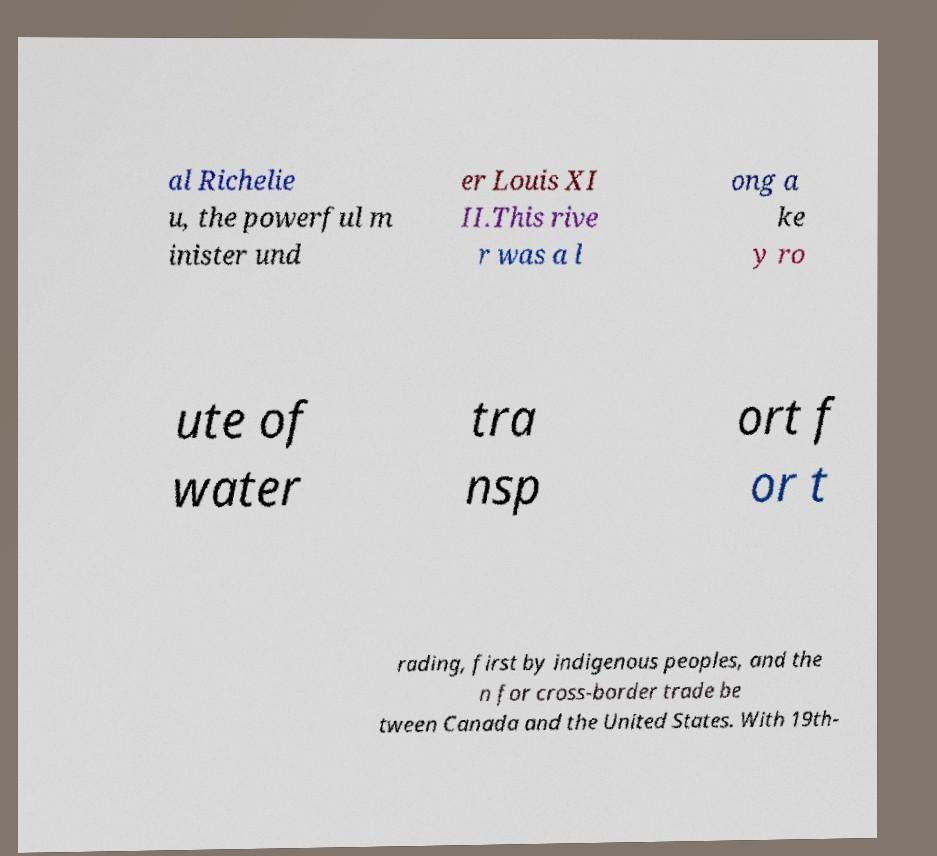There's text embedded in this image that I need extracted. Can you transcribe it verbatim? al Richelie u, the powerful m inister und er Louis XI II.This rive r was a l ong a ke y ro ute of water tra nsp ort f or t rading, first by indigenous peoples, and the n for cross-border trade be tween Canada and the United States. With 19th- 